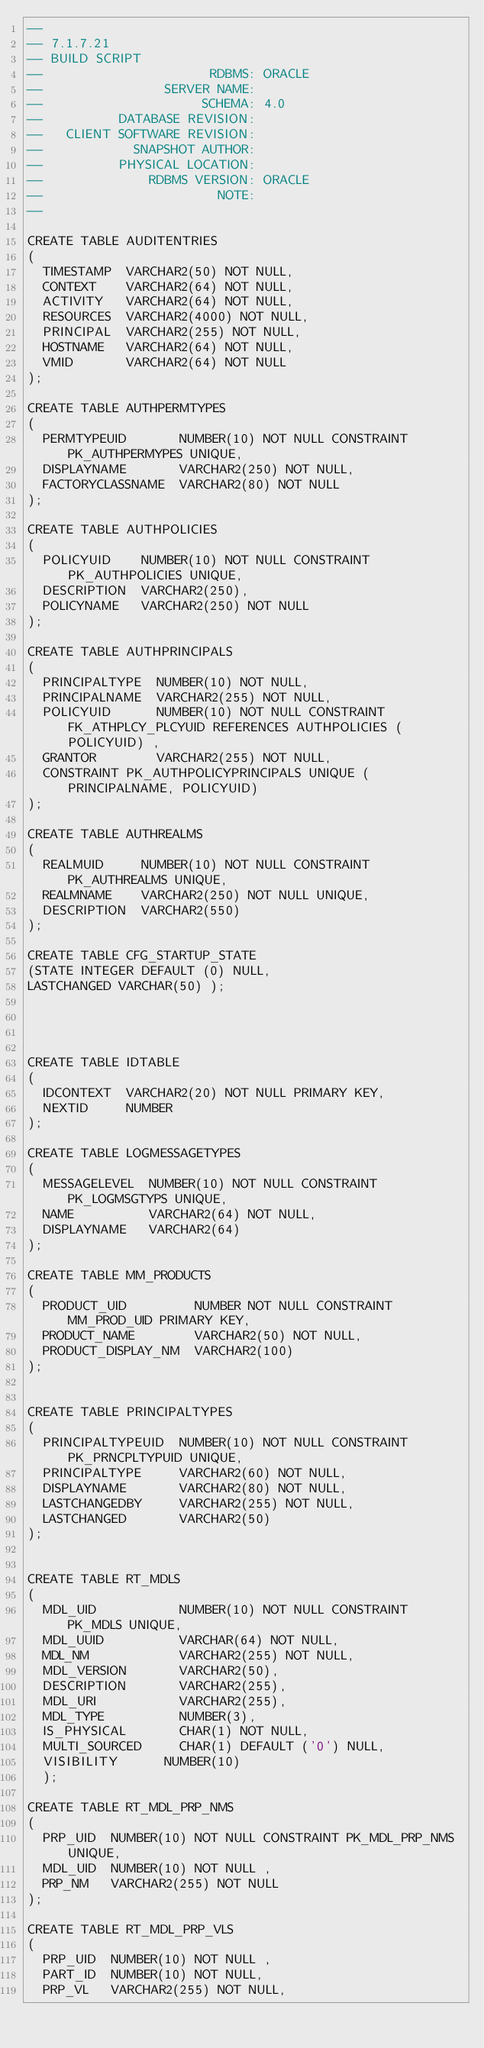Convert code to text. <code><loc_0><loc_0><loc_500><loc_500><_SQL_>--
-- 7.1.7.21
-- BUILD SCRIPT
--                      RDBMS: ORACLE
--                SERVER NAME:
--                     SCHEMA: 4.0
--          DATABASE REVISION:
--   CLIENT SOFTWARE REVISION:
--            SNAPSHOT AUTHOR:
--          PHYSICAL LOCATION:
--              RDBMS VERSION: ORACLE
--                       NOTE:
--

CREATE TABLE AUDITENTRIES
(
  TIMESTAMP  VARCHAR2(50) NOT NULL,
  CONTEXT    VARCHAR2(64) NOT NULL,
  ACTIVITY   VARCHAR2(64) NOT NULL,
  RESOURCES  VARCHAR2(4000) NOT NULL,
  PRINCIPAL  VARCHAR2(255) NOT NULL,
  HOSTNAME   VARCHAR2(64) NOT NULL,
  VMID       VARCHAR2(64) NOT NULL
);

CREATE TABLE AUTHPERMTYPES
(
  PERMTYPEUID       NUMBER(10) NOT NULL CONSTRAINT PK_AUTHPERMYPES UNIQUE,
  DISPLAYNAME       VARCHAR2(250) NOT NULL,
  FACTORYCLASSNAME  VARCHAR2(80) NOT NULL
);

CREATE TABLE AUTHPOLICIES
(
  POLICYUID    NUMBER(10) NOT NULL CONSTRAINT PK_AUTHPOLICIES UNIQUE,
  DESCRIPTION  VARCHAR2(250),
  POLICYNAME   VARCHAR2(250) NOT NULL
);

CREATE TABLE AUTHPRINCIPALS
(
  PRINCIPALTYPE  NUMBER(10) NOT NULL,
  PRINCIPALNAME  VARCHAR2(255) NOT NULL,
  POLICYUID      NUMBER(10) NOT NULL CONSTRAINT FK_ATHPLCY_PLCYUID REFERENCES AUTHPOLICIES (POLICYUID) ,
  GRANTOR        VARCHAR2(255) NOT NULL,
  CONSTRAINT PK_AUTHPOLICYPRINCIPALS UNIQUE (PRINCIPALNAME, POLICYUID)
);

CREATE TABLE AUTHREALMS
(
  REALMUID     NUMBER(10) NOT NULL CONSTRAINT PK_AUTHREALMS UNIQUE,
  REALMNAME    VARCHAR2(250) NOT NULL UNIQUE,
  DESCRIPTION  VARCHAR2(550)
);

CREATE TABLE CFG_STARTUP_STATE
(STATE INTEGER DEFAULT (0) NULL,
LASTCHANGED VARCHAR(50) );




CREATE TABLE IDTABLE
(
  IDCONTEXT  VARCHAR2(20) NOT NULL PRIMARY KEY,
  NEXTID     NUMBER
);

CREATE TABLE LOGMESSAGETYPES
(
  MESSAGELEVEL  NUMBER(10) NOT NULL CONSTRAINT PK_LOGMSGTYPS UNIQUE,
  NAME          VARCHAR2(64) NOT NULL,
  DISPLAYNAME   VARCHAR2(64)
);

CREATE TABLE MM_PRODUCTS
(
  PRODUCT_UID         NUMBER NOT NULL CONSTRAINT MM_PROD_UID PRIMARY KEY,
  PRODUCT_NAME        VARCHAR2(50) NOT NULL,
  PRODUCT_DISPLAY_NM  VARCHAR2(100)
);


CREATE TABLE PRINCIPALTYPES
(
  PRINCIPALTYPEUID  NUMBER(10) NOT NULL CONSTRAINT PK_PRNCPLTYPUID UNIQUE,
  PRINCIPALTYPE     VARCHAR2(60) NOT NULL,
  DISPLAYNAME       VARCHAR2(80) NOT NULL,
  LASTCHANGEDBY     VARCHAR2(255) NOT NULL,
  LASTCHANGED       VARCHAR2(50)
);


CREATE TABLE RT_MDLS
(
  MDL_UID           NUMBER(10) NOT NULL CONSTRAINT PK_MDLS UNIQUE,
  MDL_UUID          VARCHAR(64) NOT NULL,
  MDL_NM            VARCHAR2(255) NOT NULL,
  MDL_VERSION       VARCHAR2(50),
  DESCRIPTION       VARCHAR2(255),
  MDL_URI           VARCHAR2(255),
  MDL_TYPE          NUMBER(3),
  IS_PHYSICAL       CHAR(1) NOT NULL,
  MULTI_SOURCED     CHAR(1) DEFAULT ('0') NULL,  
  VISIBILITY      NUMBER(10)
  );

CREATE TABLE RT_MDL_PRP_NMS
(
  PRP_UID  NUMBER(10) NOT NULL CONSTRAINT PK_MDL_PRP_NMS UNIQUE,
  MDL_UID  NUMBER(10) NOT NULL ,
  PRP_NM   VARCHAR2(255) NOT NULL
);

CREATE TABLE RT_MDL_PRP_VLS
(
  PRP_UID  NUMBER(10) NOT NULL ,
  PART_ID  NUMBER(10) NOT NULL,
  PRP_VL   VARCHAR2(255) NOT NULL,</code> 